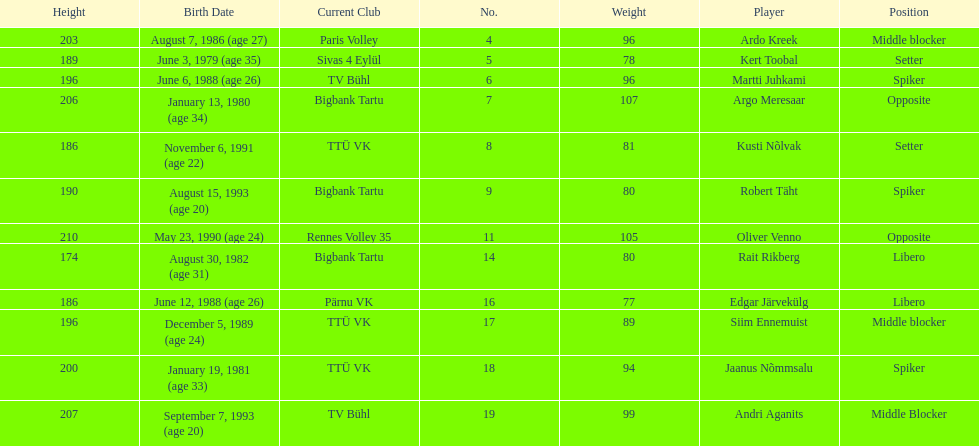Which player is taller than andri agantis? Oliver Venno. Could you parse the entire table as a dict? {'header': ['Height', 'Birth Date', 'Current Club', 'No.', 'Weight', 'Player', 'Position'], 'rows': [['203', 'August 7, 1986 (age\xa027)', 'Paris Volley', '4', '96', 'Ardo Kreek', 'Middle blocker'], ['189', 'June 3, 1979 (age\xa035)', 'Sivas 4 Eylül', '5', '78', 'Kert Toobal', 'Setter'], ['196', 'June 6, 1988 (age\xa026)', 'TV Bühl', '6', '96', 'Martti Juhkami', 'Spiker'], ['206', 'January 13, 1980 (age\xa034)', 'Bigbank Tartu', '7', '107', 'Argo Meresaar', 'Opposite'], ['186', 'November 6, 1991 (age\xa022)', 'TTÜ VK', '8', '81', 'Kusti Nõlvak', 'Setter'], ['190', 'August 15, 1993 (age\xa020)', 'Bigbank Tartu', '9', '80', 'Robert Täht', 'Spiker'], ['210', 'May 23, 1990 (age\xa024)', 'Rennes Volley 35', '11', '105', 'Oliver Venno', 'Opposite'], ['174', 'August 30, 1982 (age\xa031)', 'Bigbank Tartu', '14', '80', 'Rait Rikberg', 'Libero'], ['186', 'June 12, 1988 (age\xa026)', 'Pärnu VK', '16', '77', 'Edgar Järvekülg', 'Libero'], ['196', 'December 5, 1989 (age\xa024)', 'TTÜ VK', '17', '89', 'Siim Ennemuist', 'Middle blocker'], ['200', 'January 19, 1981 (age\xa033)', 'TTÜ VK', '18', '94', 'Jaanus Nõmmsalu', 'Spiker'], ['207', 'September 7, 1993 (age\xa020)', 'TV Bühl', '19', '99', 'Andri Aganits', 'Middle Blocker']]} 